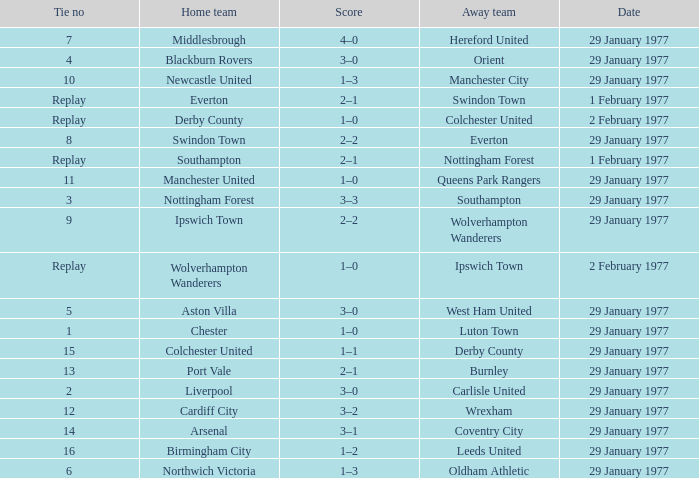What is the tie number when the home team is Port Vale? 13.0. 